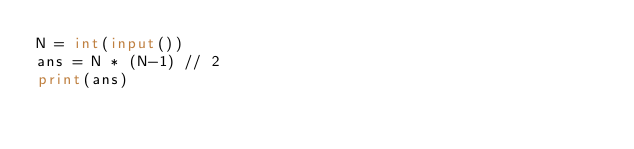<code> <loc_0><loc_0><loc_500><loc_500><_Python_>N = int(input())
ans = N * (N-1) // 2
print(ans)
</code> 